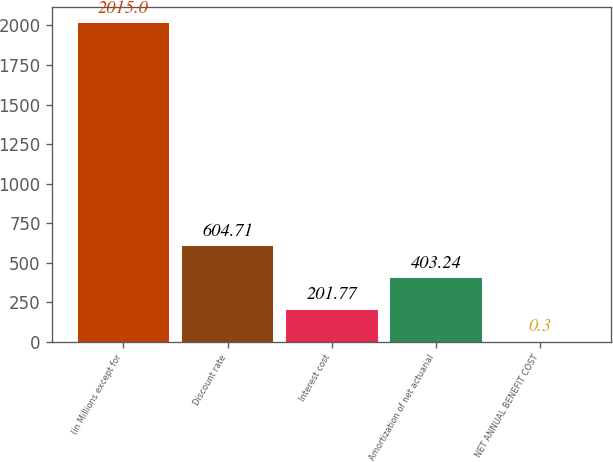Convert chart. <chart><loc_0><loc_0><loc_500><loc_500><bar_chart><fcel>(in Millions except for<fcel>Discount rate<fcel>Interest cost<fcel>Amortization of net actuarial<fcel>NET ANNUAL BENEFIT COST<nl><fcel>2015<fcel>604.71<fcel>201.77<fcel>403.24<fcel>0.3<nl></chart> 